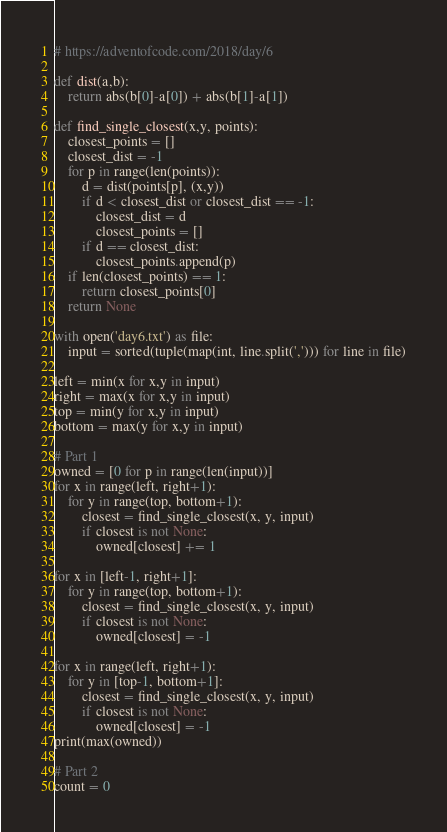<code> <loc_0><loc_0><loc_500><loc_500><_Python_># https://adventofcode.com/2018/day/6

def dist(a,b):
    return abs(b[0]-a[0]) + abs(b[1]-a[1])

def find_single_closest(x,y, points):
    closest_points = []
    closest_dist = -1
    for p in range(len(points)):
        d = dist(points[p], (x,y))
        if d < closest_dist or closest_dist == -1:
            closest_dist = d
            closest_points = []
        if d == closest_dist:
            closest_points.append(p)
    if len(closest_points) == 1:
        return closest_points[0]
    return None

with open('day6.txt') as file:
    input = sorted(tuple(map(int, line.split(','))) for line in file)

left = min(x for x,y in input)
right = max(x for x,y in input)
top = min(y for x,y in input)
bottom = max(y for x,y in input)

# Part 1
owned = [0 for p in range(len(input))]
for x in range(left, right+1):
    for y in range(top, bottom+1):
        closest = find_single_closest(x, y, input)
        if closest is not None:
            owned[closest] += 1

for x in [left-1, right+1]:
    for y in range(top, bottom+1):
        closest = find_single_closest(x, y, input)
        if closest is not None:
            owned[closest] = -1

for x in range(left, right+1):
    for y in [top-1, bottom+1]:
        closest = find_single_closest(x, y, input)
        if closest is not None:
            owned[closest] = -1
print(max(owned))

# Part 2
count = 0</code> 